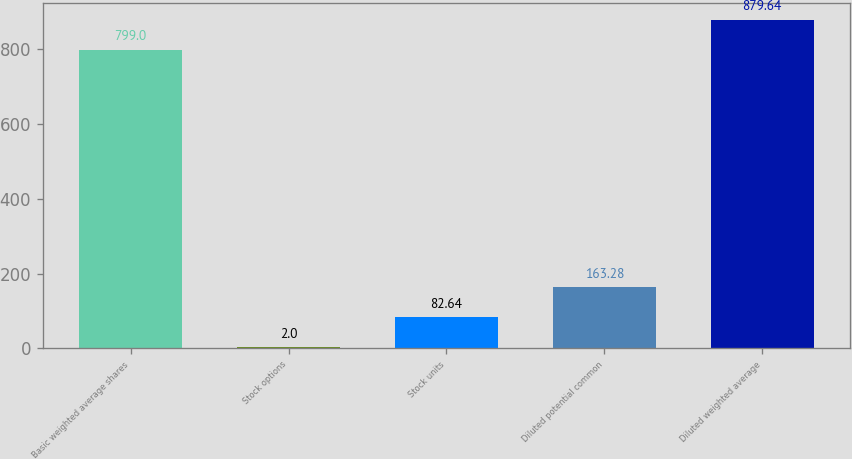Convert chart. <chart><loc_0><loc_0><loc_500><loc_500><bar_chart><fcel>Basic weighted average shares<fcel>Stock options<fcel>Stock units<fcel>Diluted potential common<fcel>Diluted weighted average<nl><fcel>799<fcel>2<fcel>82.64<fcel>163.28<fcel>879.64<nl></chart> 